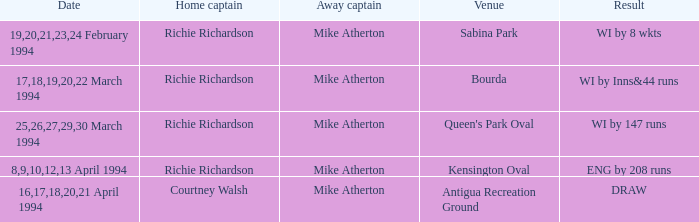Which Home Captain has Eng by 208 runs? Richie Richardson. 